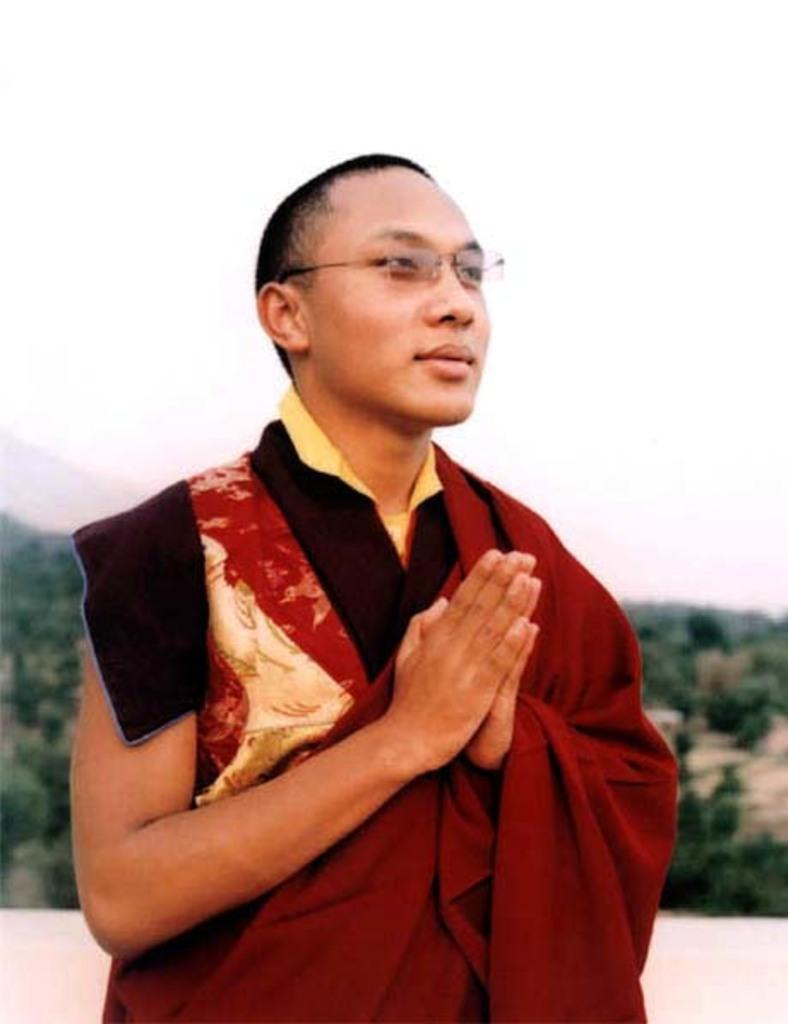What is the main subject of the image? There is a man standing in the center of the image. Can you describe the man's appearance? The man is wearing spectacles. What can be seen in the background of the image? There are trees in the background of the image. What is visible at the top of the image? The sky is visible at the top of the image. What type of jelly can be seen on the man's shoes in the image? There is no jelly visible on the man's shoes in the image. How many parts of the tramp can be seen in the image? There is no tramp present in the image. 